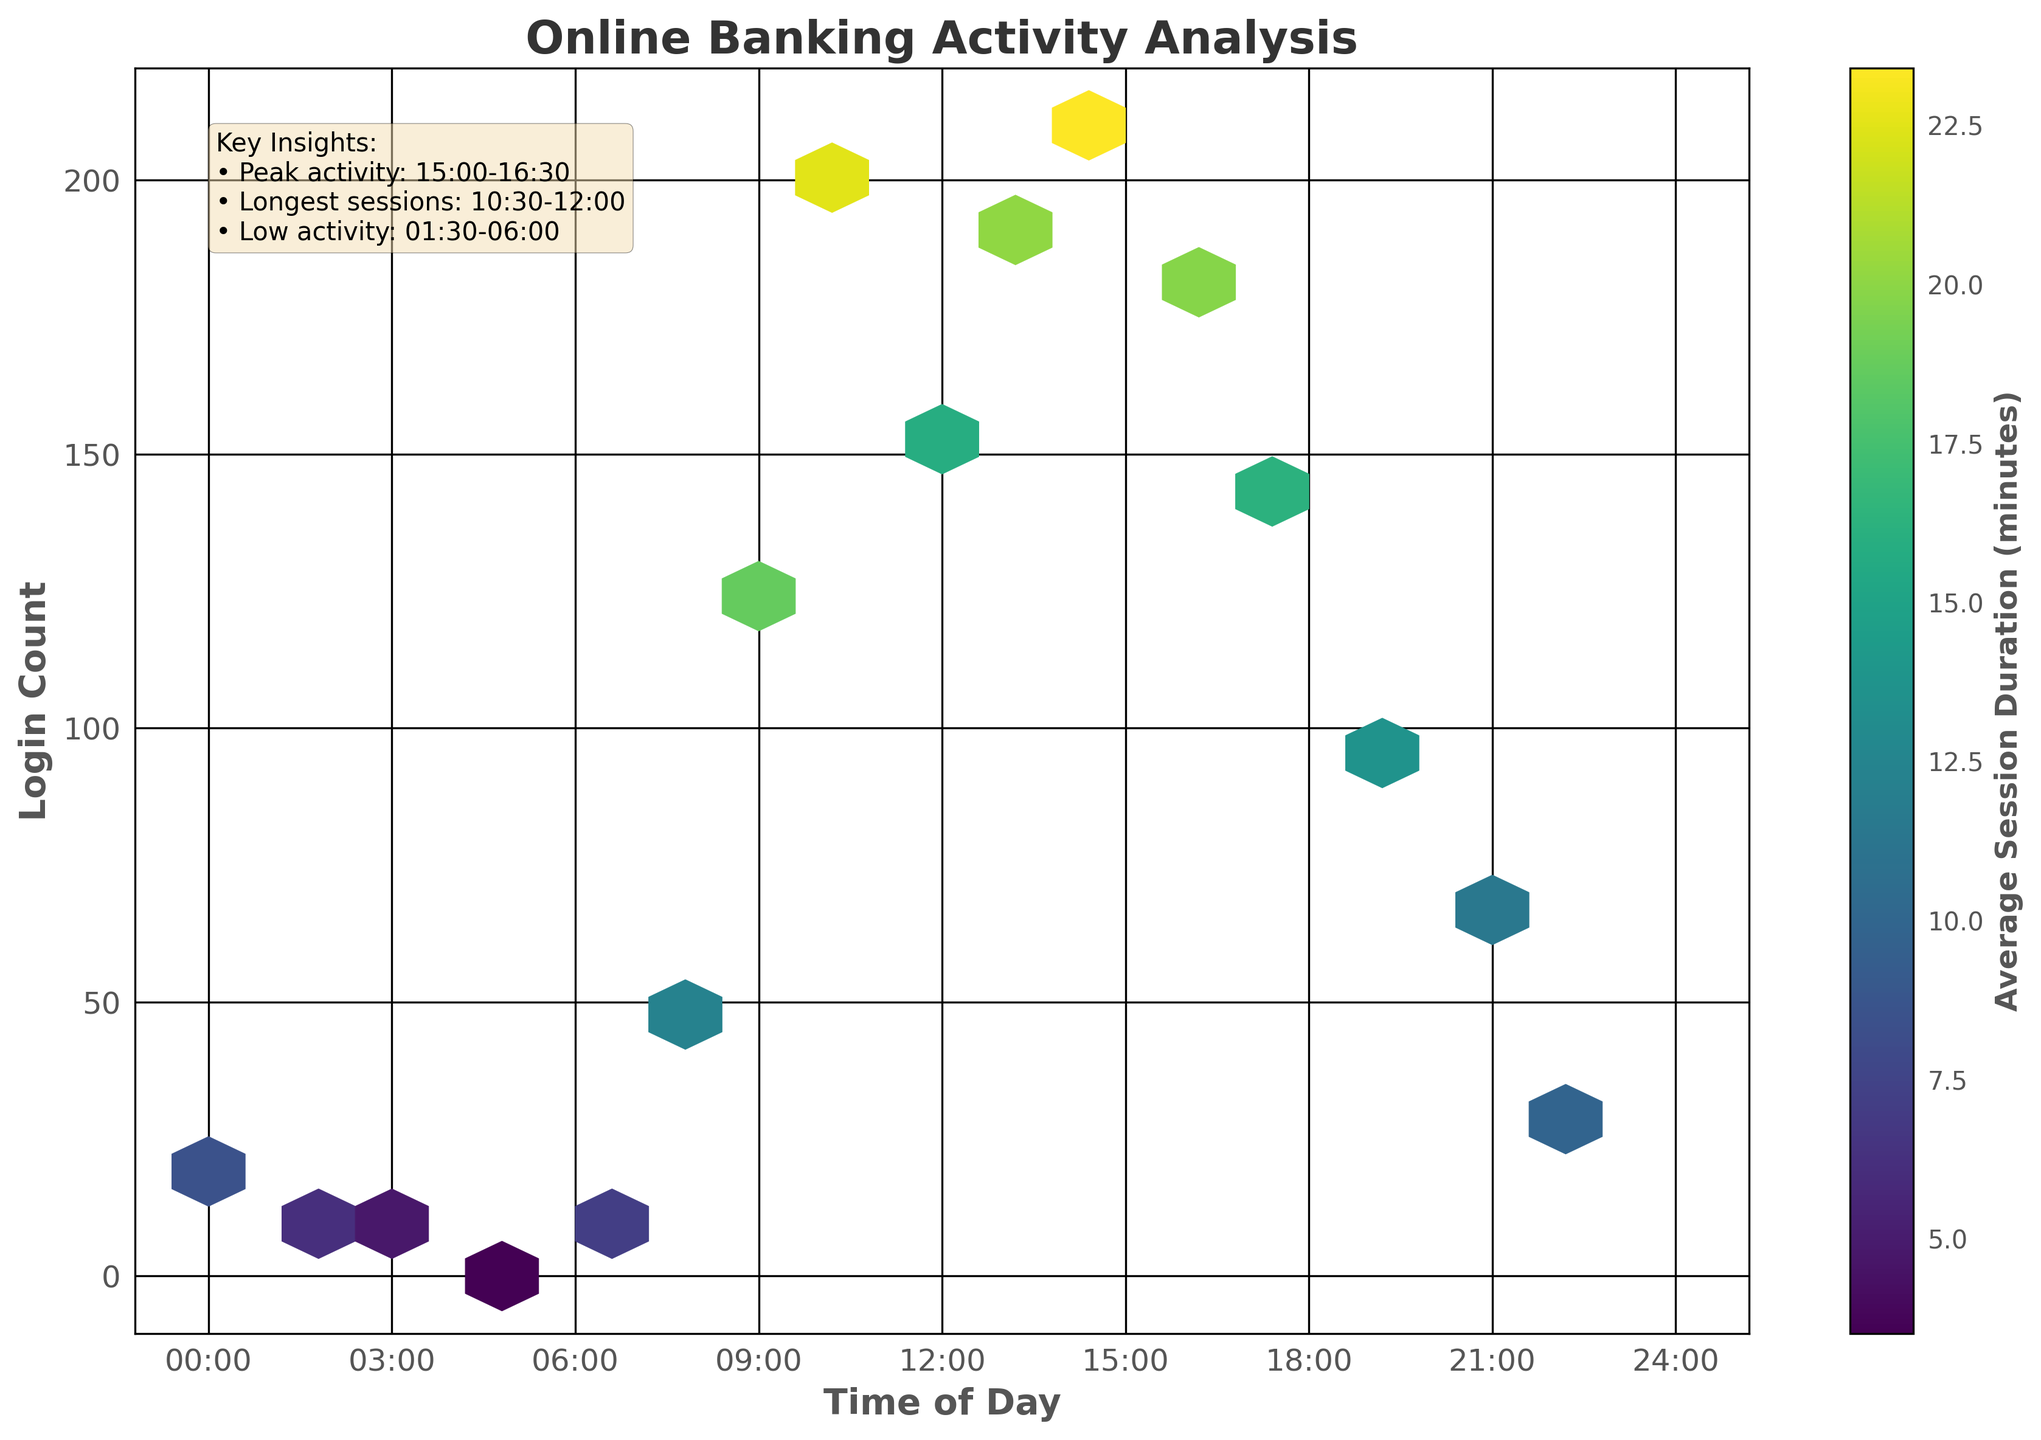What is the title of the plot? The title of the plot is displayed at the top of the figure. It provides an overview of the subject the plot represents.
Answer: Online Banking Activity Analysis What are the labels on the x-axis and y-axis? The labels on the axes identify the variables being represented. The x-axis represents the time of the day, and the y-axis represents the login count.
Answer: x-axis: Time of Day, y-axis: Login Count How do the session durations vary throughout the day? The color bar to the right of the plot indicates session durations with different colors. By examining the colors in the hexbin plot, one can see that session durations are longer (darker colors) around specific times of the day, such as 10:30-12:00.
Answer: Sessions are longer around 10:30-12:00 and 15:00-16:30 What is the peak activity time for logins? From the key insights and the highest density of hexagons in the hexbin plot, we can see when login activity is the highest. The peak activity time is noted around 15:00.
Answer: 15:00-16:30 During which time interval do we observe the longest session durations? The color intensities (darker shades) in the plot signify average session durations. By identifying the darkest hexagons, we can see longer sessions. The longest session durations are observed around 10:30-12:00.
Answer: 10:30-12:00 How does the login activity between 03:00 and 06:00 compare to the activity between 09:00 and 15:00? By comparing the density of hexagons during 03:00-06:00 and 09:00-15:00, it is clear that there are very few logins in early hours and much higher activity in later hours.
Answer: Lower during 03:00-06:00; Higher in 09:00-15:00 Which time period has the lowest login activity? Observing the density of hexagons and from the key insights, the period with the least hexagons indicates the lowest activity. The lowest login activity is observed between 01:30 and 06:00.
Answer: 01:30-06:00 What is the range of login counts shown in the plot? The y-axis provides the range of login counts, starting from zero to the maximum value indicated in the plot. The range can be observed from the y-axis ticks.
Answer: 0 to 210 Compare the average session duration at 16:30 and 22:30. By examining the intensity of colors at 16:30 and 22:30 on the hexbin plot, we can compare which time has a darker color indicating a longer average session duration. The average session duration at 16:30 is longer than 22:30.
Answer: Longer at 16:30 What are the key insights provided in the plot? The text box on the plot lists key observations regarding peak activity times, session durations, and periods of low activity. These insights are summarized to highlight important findings.
Answer: Peak activity: 15:00-16:30; Longest sessions: 10:30-12:00; Low activity: 01:30-06:00 